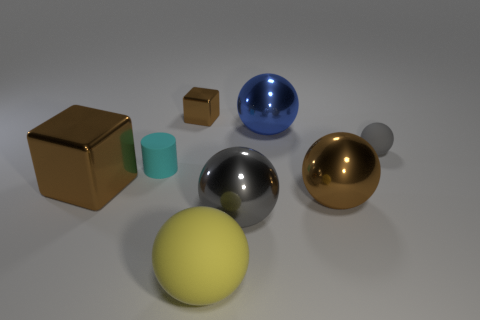What is the size of the metallic sphere that is the same color as the tiny shiny object?
Your answer should be compact. Large. Are there fewer large cubes to the right of the small gray rubber ball than spheres that are right of the big blue metal sphere?
Provide a succinct answer. Yes. The gray matte thing that is the same shape as the big blue shiny object is what size?
Your answer should be very brief. Small. Are there any other things that are the same size as the gray matte thing?
Provide a succinct answer. Yes. What number of objects are either gray things that are to the right of the large brown ball or balls left of the gray rubber sphere?
Offer a very short reply. 5. Does the blue shiny ball have the same size as the yellow matte ball?
Your answer should be compact. Yes. Are there more large brown balls than green matte balls?
Your answer should be compact. Yes. What number of other things are the same color as the small ball?
Provide a succinct answer. 1. How many objects are tiny gray metal cylinders or large metal things?
Your response must be concise. 4. There is a big metal thing left of the tiny brown metallic block; is it the same shape as the tiny gray object?
Provide a short and direct response. No. 